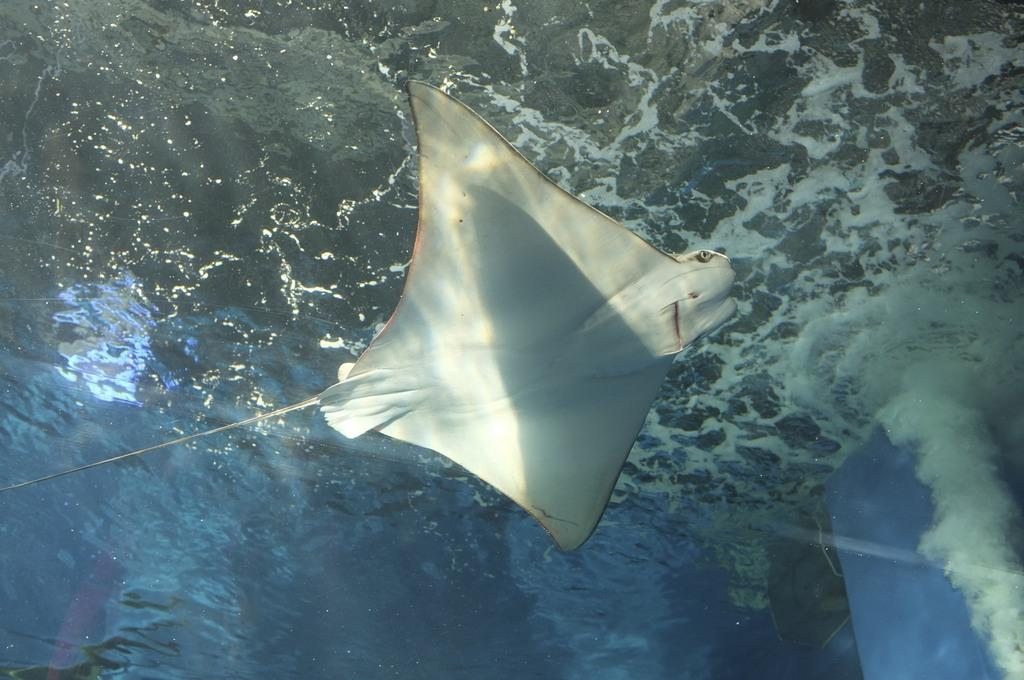What type of animal is in the image? There is an aquatic animal in the image, specifically a skate. Where is the skate located in the image? The skate is in the water. What decision does the skate make in the image? The skate does not make any decisions in the image, as it is an animal and not capable of making decisions. 